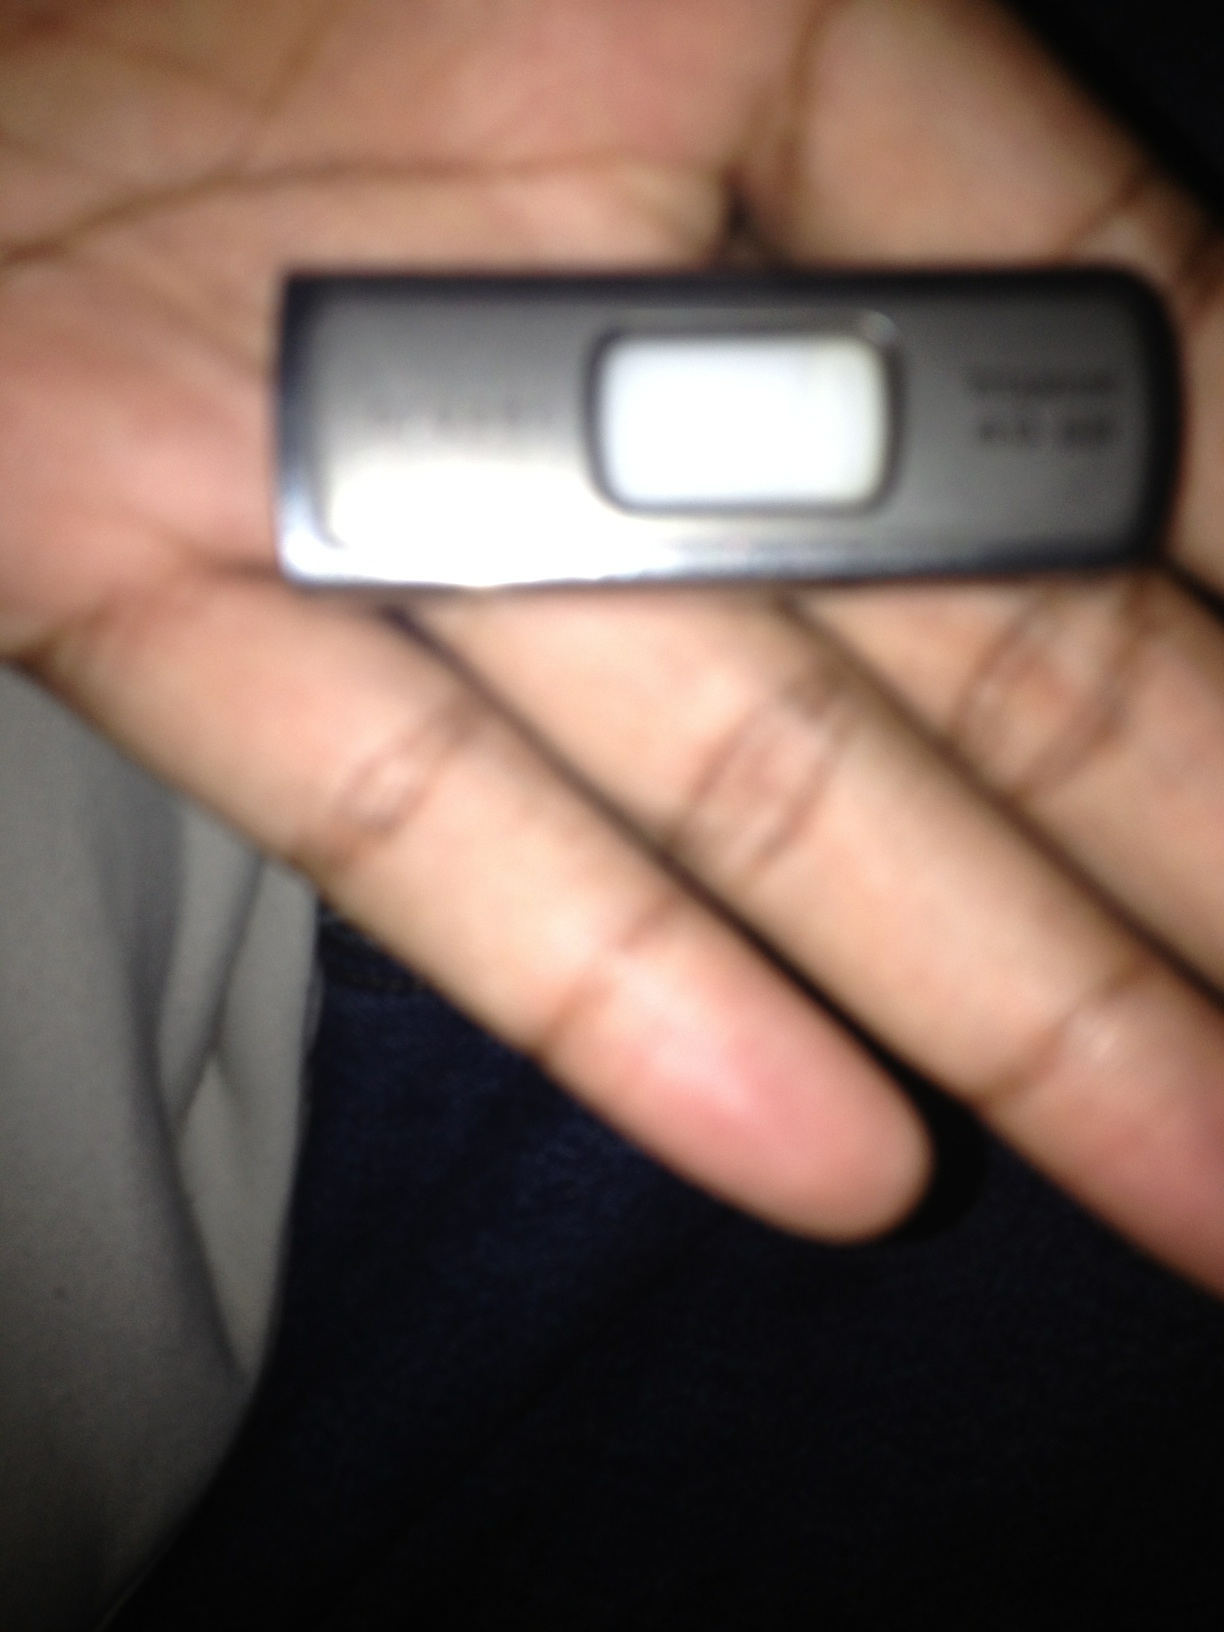Can you give an example of a real-world scenario where this device could be used? Certainly! A professional photographer might use a USB flash drive to store and transfer high-resolution images from a photoshoot to a client's computer. After completing the photoshoot, the photographer can quickly move the large image files from their camera to the flash drive, then plug the flash drive into the client's computer for a fast and efficient transfer of the photos. 